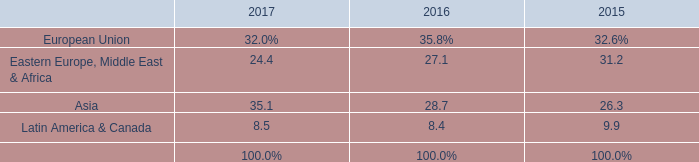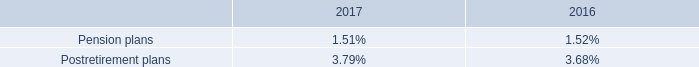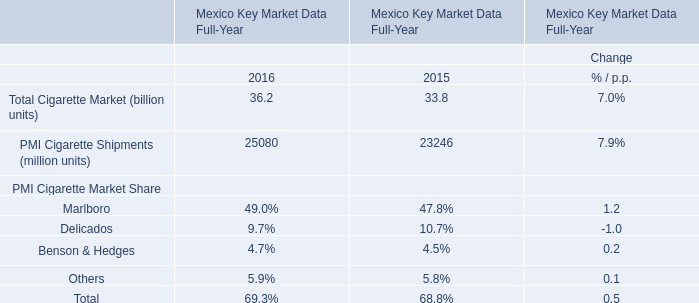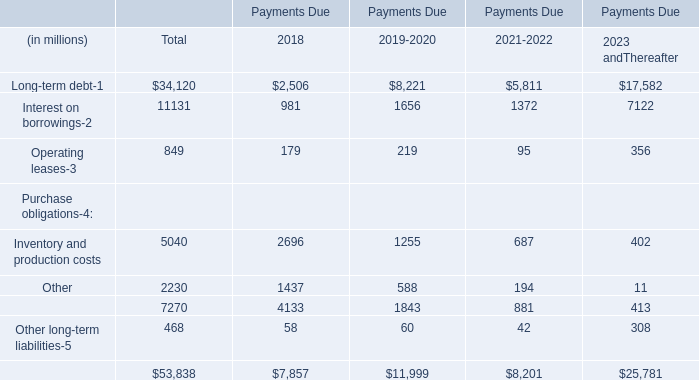Does Inventory and production costs debt keeps increasing each year between 2018 and 2019? 
Answer: no. 